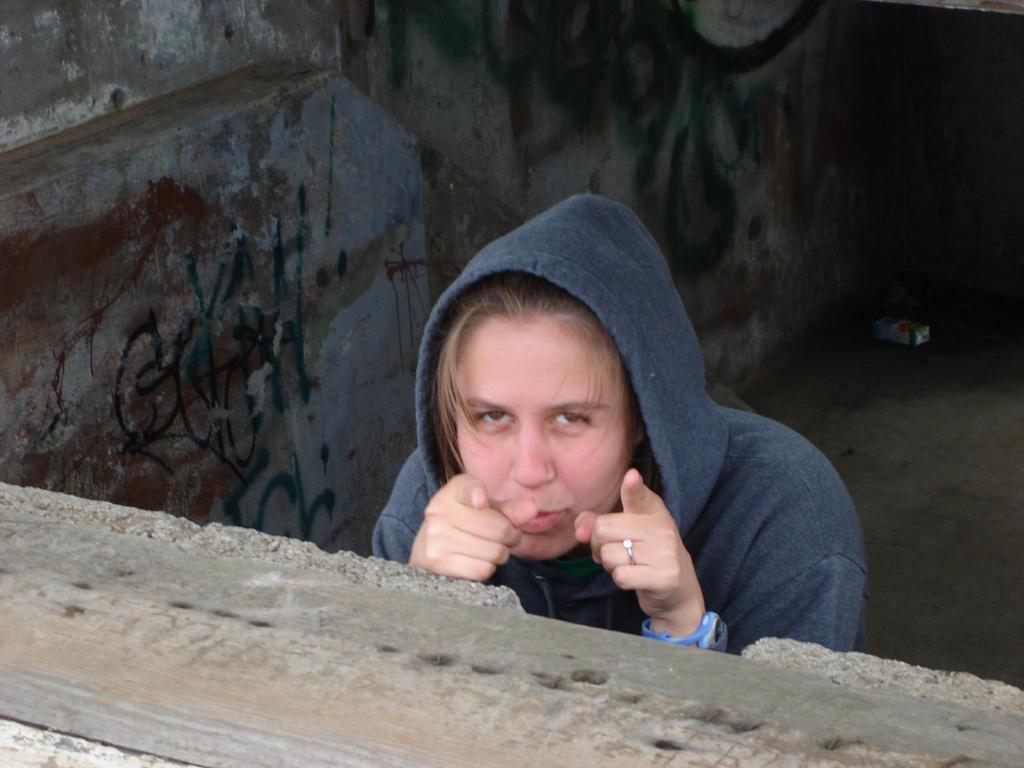Please provide a concise description of this image. Here in this picture we can see a woman present over a place and we can see she is wearing a hoodie, a ring and a watch on her. 